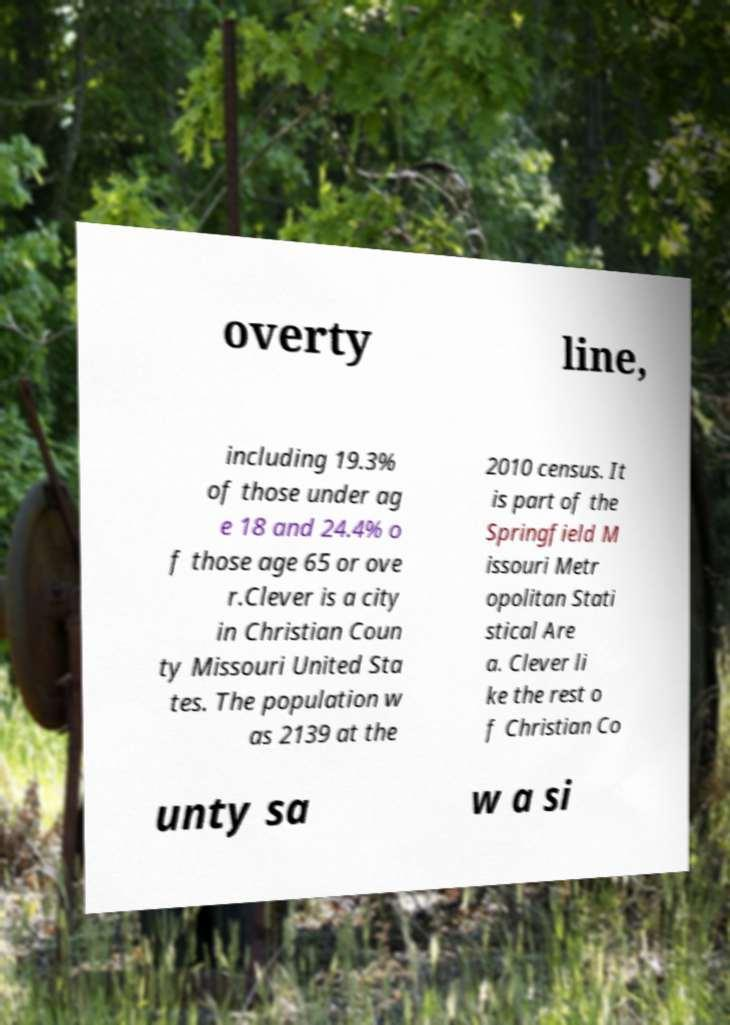Can you accurately transcribe the text from the provided image for me? overty line, including 19.3% of those under ag e 18 and 24.4% o f those age 65 or ove r.Clever is a city in Christian Coun ty Missouri United Sta tes. The population w as 2139 at the 2010 census. It is part of the Springfield M issouri Metr opolitan Stati stical Are a. Clever li ke the rest o f Christian Co unty sa w a si 